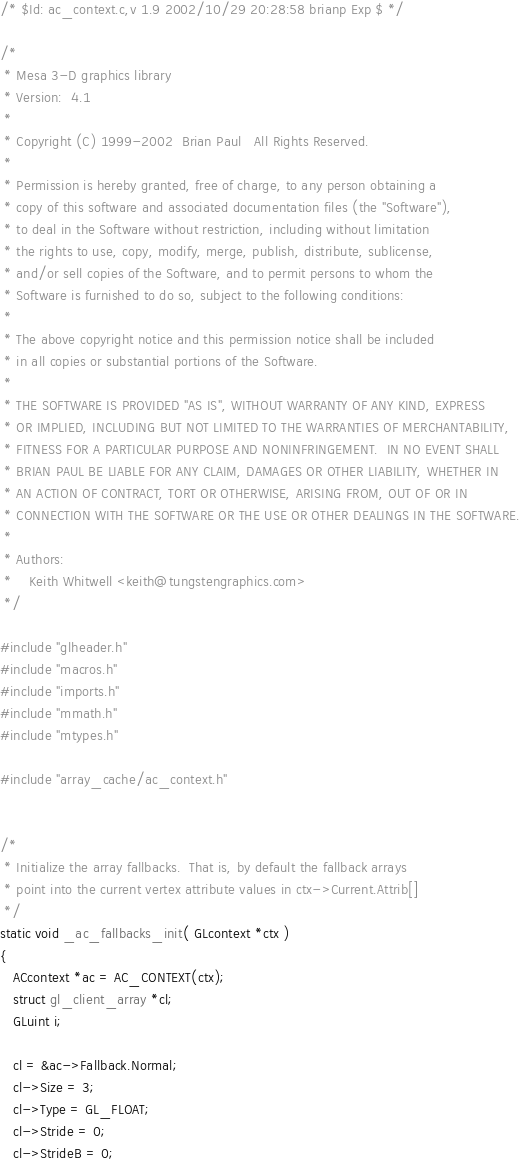Convert code to text. <code><loc_0><loc_0><loc_500><loc_500><_C++_>/* $Id: ac_context.c,v 1.9 2002/10/29 20:28:58 brianp Exp $ */

/*
 * Mesa 3-D graphics library
 * Version:  4.1
 *
 * Copyright (C) 1999-2002  Brian Paul   All Rights Reserved.
 *
 * Permission is hereby granted, free of charge, to any person obtaining a
 * copy of this software and associated documentation files (the "Software"),
 * to deal in the Software without restriction, including without limitation
 * the rights to use, copy, modify, merge, publish, distribute, sublicense,
 * and/or sell copies of the Software, and to permit persons to whom the
 * Software is furnished to do so, subject to the following conditions:
 *
 * The above copyright notice and this permission notice shall be included
 * in all copies or substantial portions of the Software.
 *
 * THE SOFTWARE IS PROVIDED "AS IS", WITHOUT WARRANTY OF ANY KIND, EXPRESS
 * OR IMPLIED, INCLUDING BUT NOT LIMITED TO THE WARRANTIES OF MERCHANTABILITY,
 * FITNESS FOR A PARTICULAR PURPOSE AND NONINFRINGEMENT.  IN NO EVENT SHALL
 * BRIAN PAUL BE LIABLE FOR ANY CLAIM, DAMAGES OR OTHER LIABILITY, WHETHER IN
 * AN ACTION OF CONTRACT, TORT OR OTHERWISE, ARISING FROM, OUT OF OR IN
 * CONNECTION WITH THE SOFTWARE OR THE USE OR OTHER DEALINGS IN THE SOFTWARE.
 *
 * Authors:
 *    Keith Whitwell <keith@tungstengraphics.com>
 */

#include "glheader.h"
#include "macros.h"
#include "imports.h"
#include "mmath.h"
#include "mtypes.h"

#include "array_cache/ac_context.h"


/*
 * Initialize the array fallbacks.  That is, by default the fallback arrays
 * point into the current vertex attribute values in ctx->Current.Attrib[]
 */
static void _ac_fallbacks_init( GLcontext *ctx )
{
   ACcontext *ac = AC_CONTEXT(ctx);
   struct gl_client_array *cl;
   GLuint i;

   cl = &ac->Fallback.Normal;
   cl->Size = 3;
   cl->Type = GL_FLOAT;
   cl->Stride = 0;
   cl->StrideB = 0;</code> 